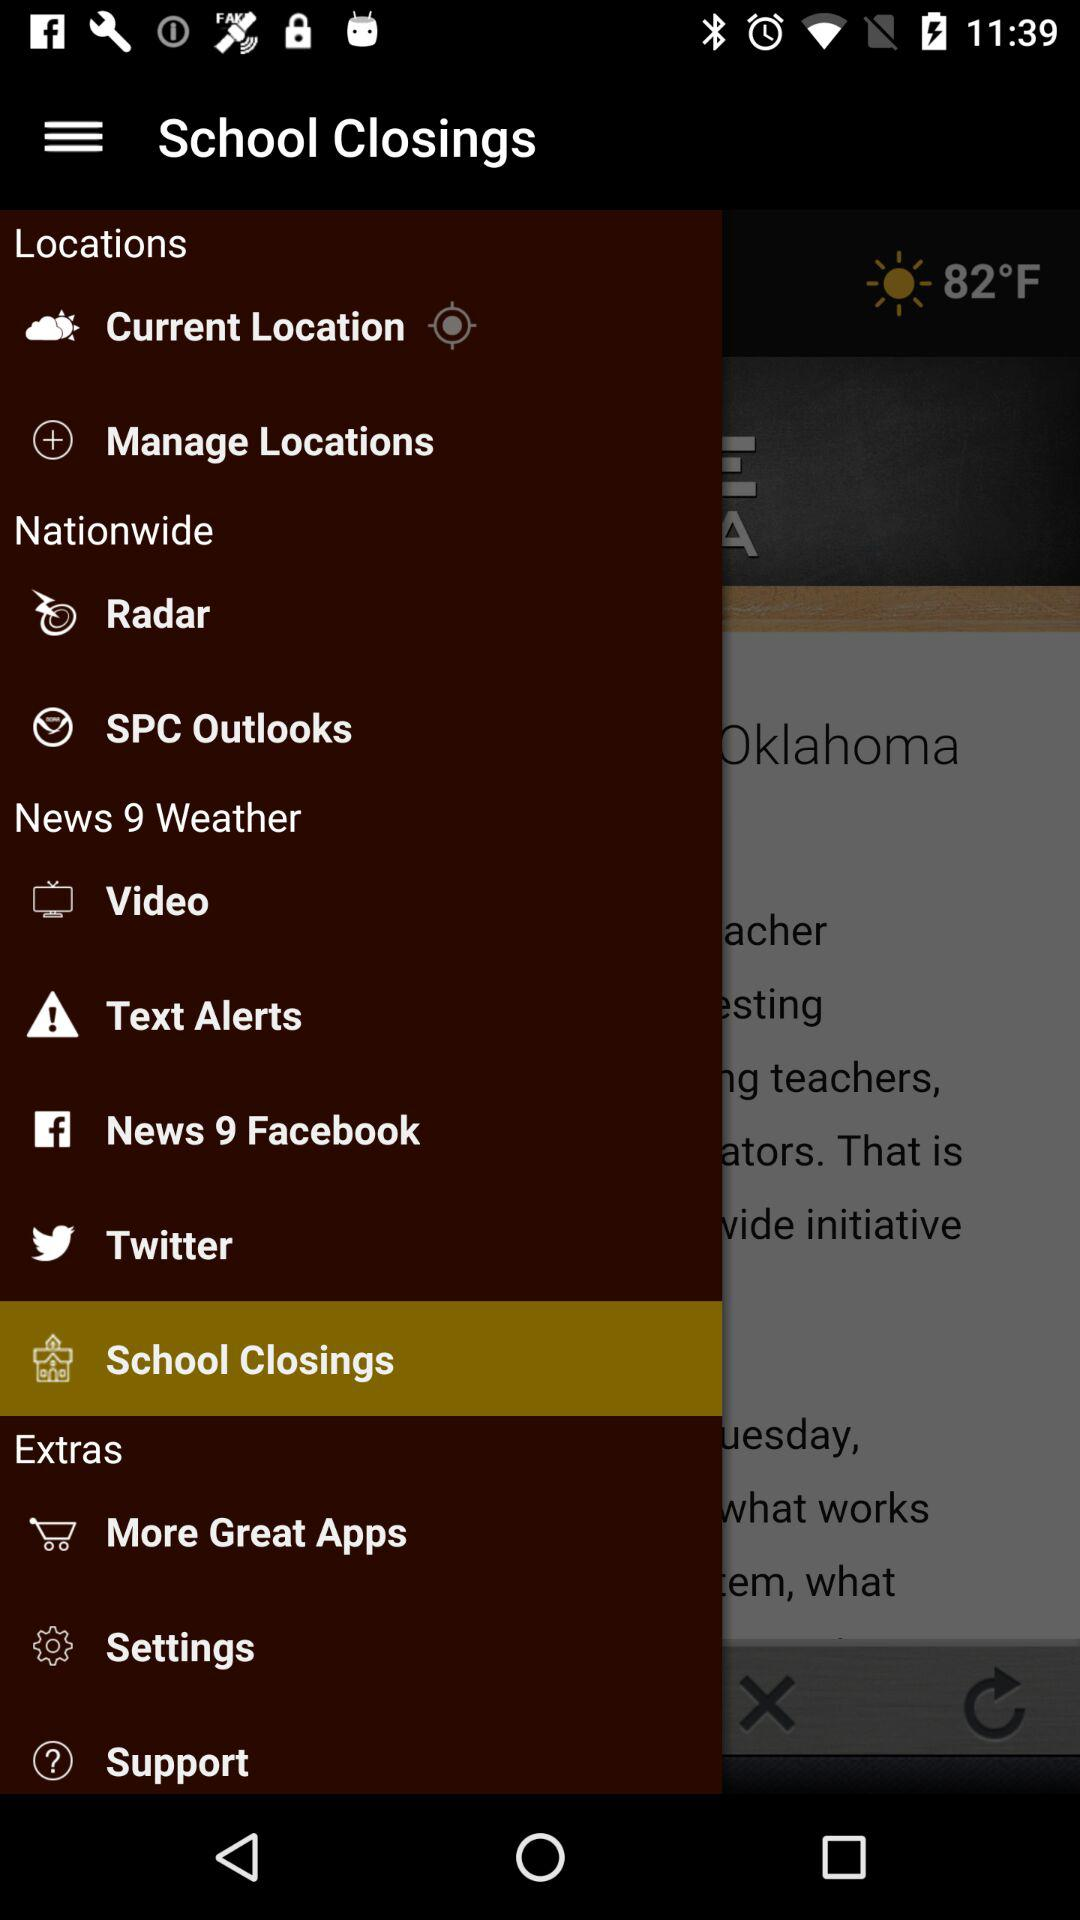What is the temperature shown on the screen? The temperature shown on the screen is 82 °F. 